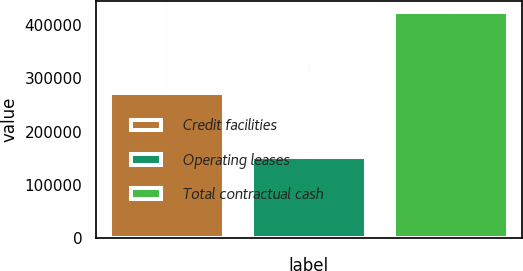<chart> <loc_0><loc_0><loc_500><loc_500><bar_chart><fcel>Credit facilities<fcel>Operating leases<fcel>Total contractual cash<nl><fcel>272400<fcel>152300<fcel>424700<nl></chart> 